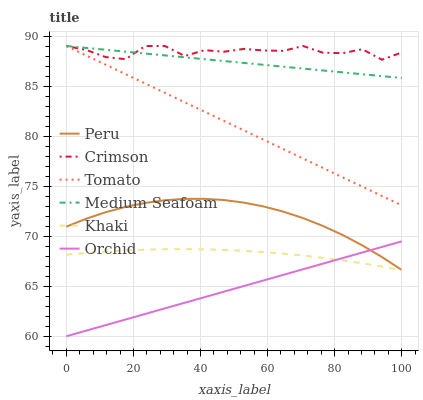Does Orchid have the minimum area under the curve?
Answer yes or no. Yes. Does Crimson have the maximum area under the curve?
Answer yes or no. Yes. Does Khaki have the minimum area under the curve?
Answer yes or no. No. Does Khaki have the maximum area under the curve?
Answer yes or no. No. Is Tomato the smoothest?
Answer yes or no. Yes. Is Crimson the roughest?
Answer yes or no. Yes. Is Khaki the smoothest?
Answer yes or no. No. Is Khaki the roughest?
Answer yes or no. No. Does Orchid have the lowest value?
Answer yes or no. Yes. Does Khaki have the lowest value?
Answer yes or no. No. Does Medium Seafoam have the highest value?
Answer yes or no. Yes. Does Peru have the highest value?
Answer yes or no. No. Is Khaki less than Medium Seafoam?
Answer yes or no. Yes. Is Medium Seafoam greater than Peru?
Answer yes or no. Yes. Does Peru intersect Orchid?
Answer yes or no. Yes. Is Peru less than Orchid?
Answer yes or no. No. Is Peru greater than Orchid?
Answer yes or no. No. Does Khaki intersect Medium Seafoam?
Answer yes or no. No. 